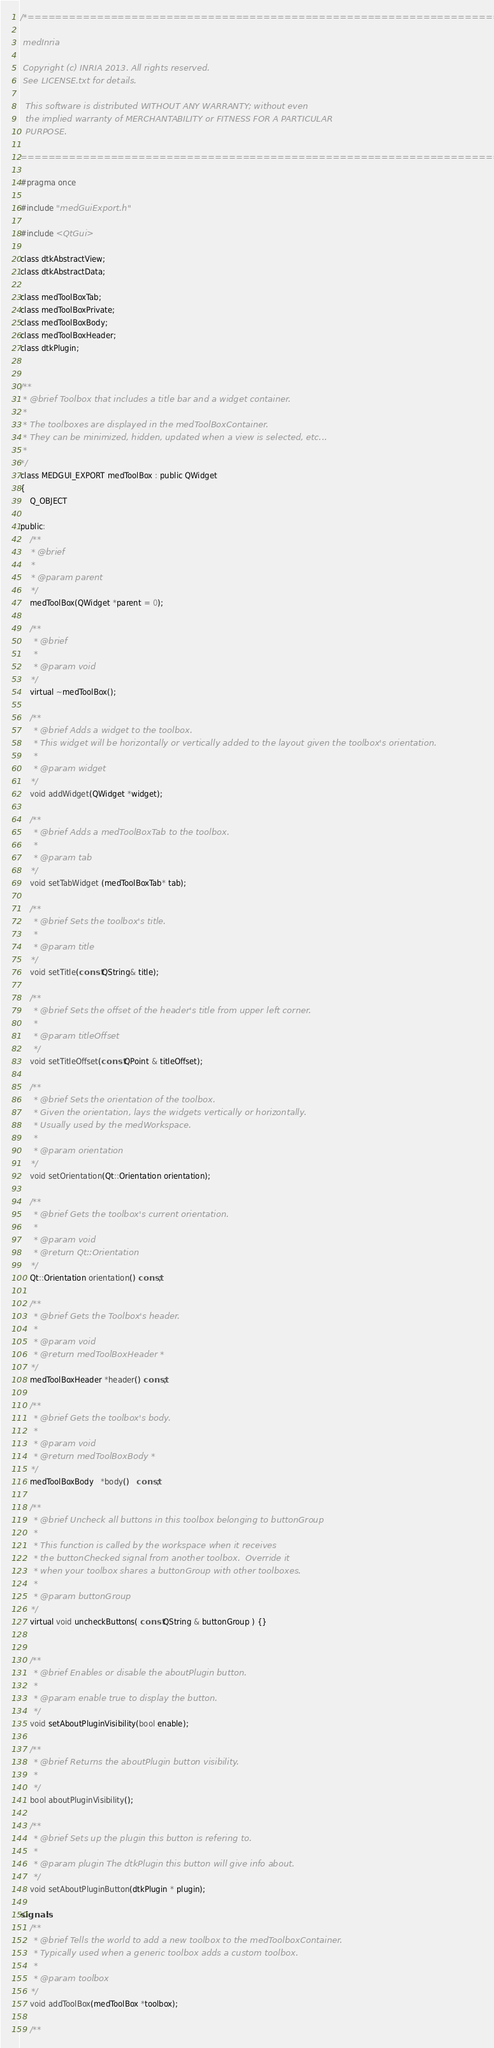Convert code to text. <code><loc_0><loc_0><loc_500><loc_500><_C_>/*=========================================================================

 medInria

 Copyright (c) INRIA 2013. All rights reserved.
 See LICENSE.txt for details.
 
  This software is distributed WITHOUT ANY WARRANTY; without even
  the implied warranty of MERCHANTABILITY or FITNESS FOR A PARTICULAR
  PURPOSE.

=========================================================================*/

#pragma once

#include "medGuiExport.h"

#include <QtGui>

class dtkAbstractView;
class dtkAbstractData;

class medToolBoxTab;
class medToolBoxPrivate;
class medToolBoxBody;
class medToolBoxHeader;
class dtkPlugin;


/**
 * @brief Toolbox that includes a title bar and a widget container.
 *
 * The toolboxes are displayed in the medToolBoxContainer.
 * They can be minimized, hidden, updated when a view is selected, etc...
 *
*/
class MEDGUI_EXPORT medToolBox : public QWidget
{
    Q_OBJECT

public:
    /**
    * @brief
    *
    * @param parent
    */
    medToolBox(QWidget *parent = 0);

    /**
     * @brief
     *
     * @param void
    */
    virtual ~medToolBox();

    /**
     * @brief Adds a widget to the toolbox.
     * This widget will be horizontally or vertically added to the layout given the toolbox's orientation.
     *
     * @param widget
    */
    void addWidget(QWidget *widget);

    /**
     * @brief Adds a medToolBoxTab to the toolbox.
     *
     * @param tab
    */
    void setTabWidget (medToolBoxTab* tab);

    /**
     * @brief Sets the toolbox's title.
     *
     * @param title
    */
    void setTitle(const QString& title);

    /**
     * @brief Sets the offset of the header's title from upper left corner.
     *
     * @param titleOffset
     */
    void setTitleOffset(const QPoint & titleOffset);

    /**
     * @brief Sets the orientation of the toolbox.
     * Given the orientation, lays the widgets vertically or horizontally.
     * Usually used by the medWorkspace.
     *
     * @param orientation
    */
    void setOrientation(Qt::Orientation orientation);

    /**
     * @brief Gets the toolbox's current orientation.
     *
     * @param void
     * @return Qt::Orientation
    */
    Qt::Orientation orientation() const;

    /**
     * @brief Gets the Toolbox's header.
     *
     * @param void
     * @return medToolBoxHeader *
    */
    medToolBoxHeader *header() const;

    /**
     * @brief Gets the toolbox's body.
     *
     * @param void
     * @return medToolBoxBody *
    */
    medToolBoxBody   *body()   const;

    /**
     * @brief Uncheck all buttons in this toolbox belonging to buttonGroup
     *
     * This function is called by the workspace when it receives
     * the buttonChecked signal from another toolbox.  Override it
     * when your toolbox shares a buttonGroup with other toolboxes.
     *
     * @param buttonGroup
    */
    virtual void uncheckButtons( const QString & buttonGroup ) {}


    /**
     * @brief Enables or disable the aboutPlugin button.
     *
     * @param enable true to display the button.
     */
    void setAboutPluginVisibility(bool enable);

    /**
     * @brief Returns the aboutPlugin button visibility.
     *
     */
    bool aboutPluginVisibility();

    /**
     * @brief Sets up the plugin this button is refering to.
     *
     * @param plugin The dtkPlugin this button will give info about.
     */
    void setAboutPluginButton(dtkPlugin * plugin);

signals:
    /**
     * @brief Tells the world to add a new toolbox to the medToolboxContainer.
     * Typically used when a generic toolbox adds a custom toolbox.
     *
     * @param toolbox
    */
    void addToolBox(medToolBox *toolbox);

    /**</code> 